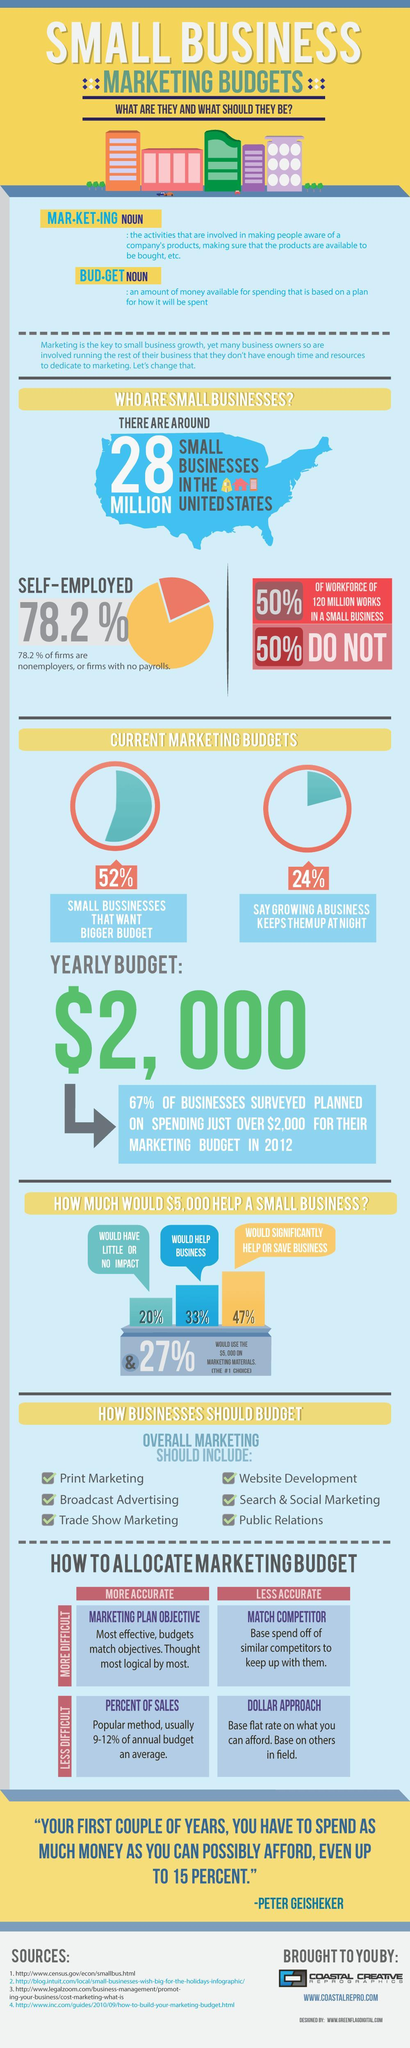What percentage of people are not self-employed?
Answer the question with a short phrase. 21.8 % Whose words are given? PETER GEISHEKER What is the colour of the US map shown - blue or red? Blue How much money will help 47% of the small businesses? $ 5,000 